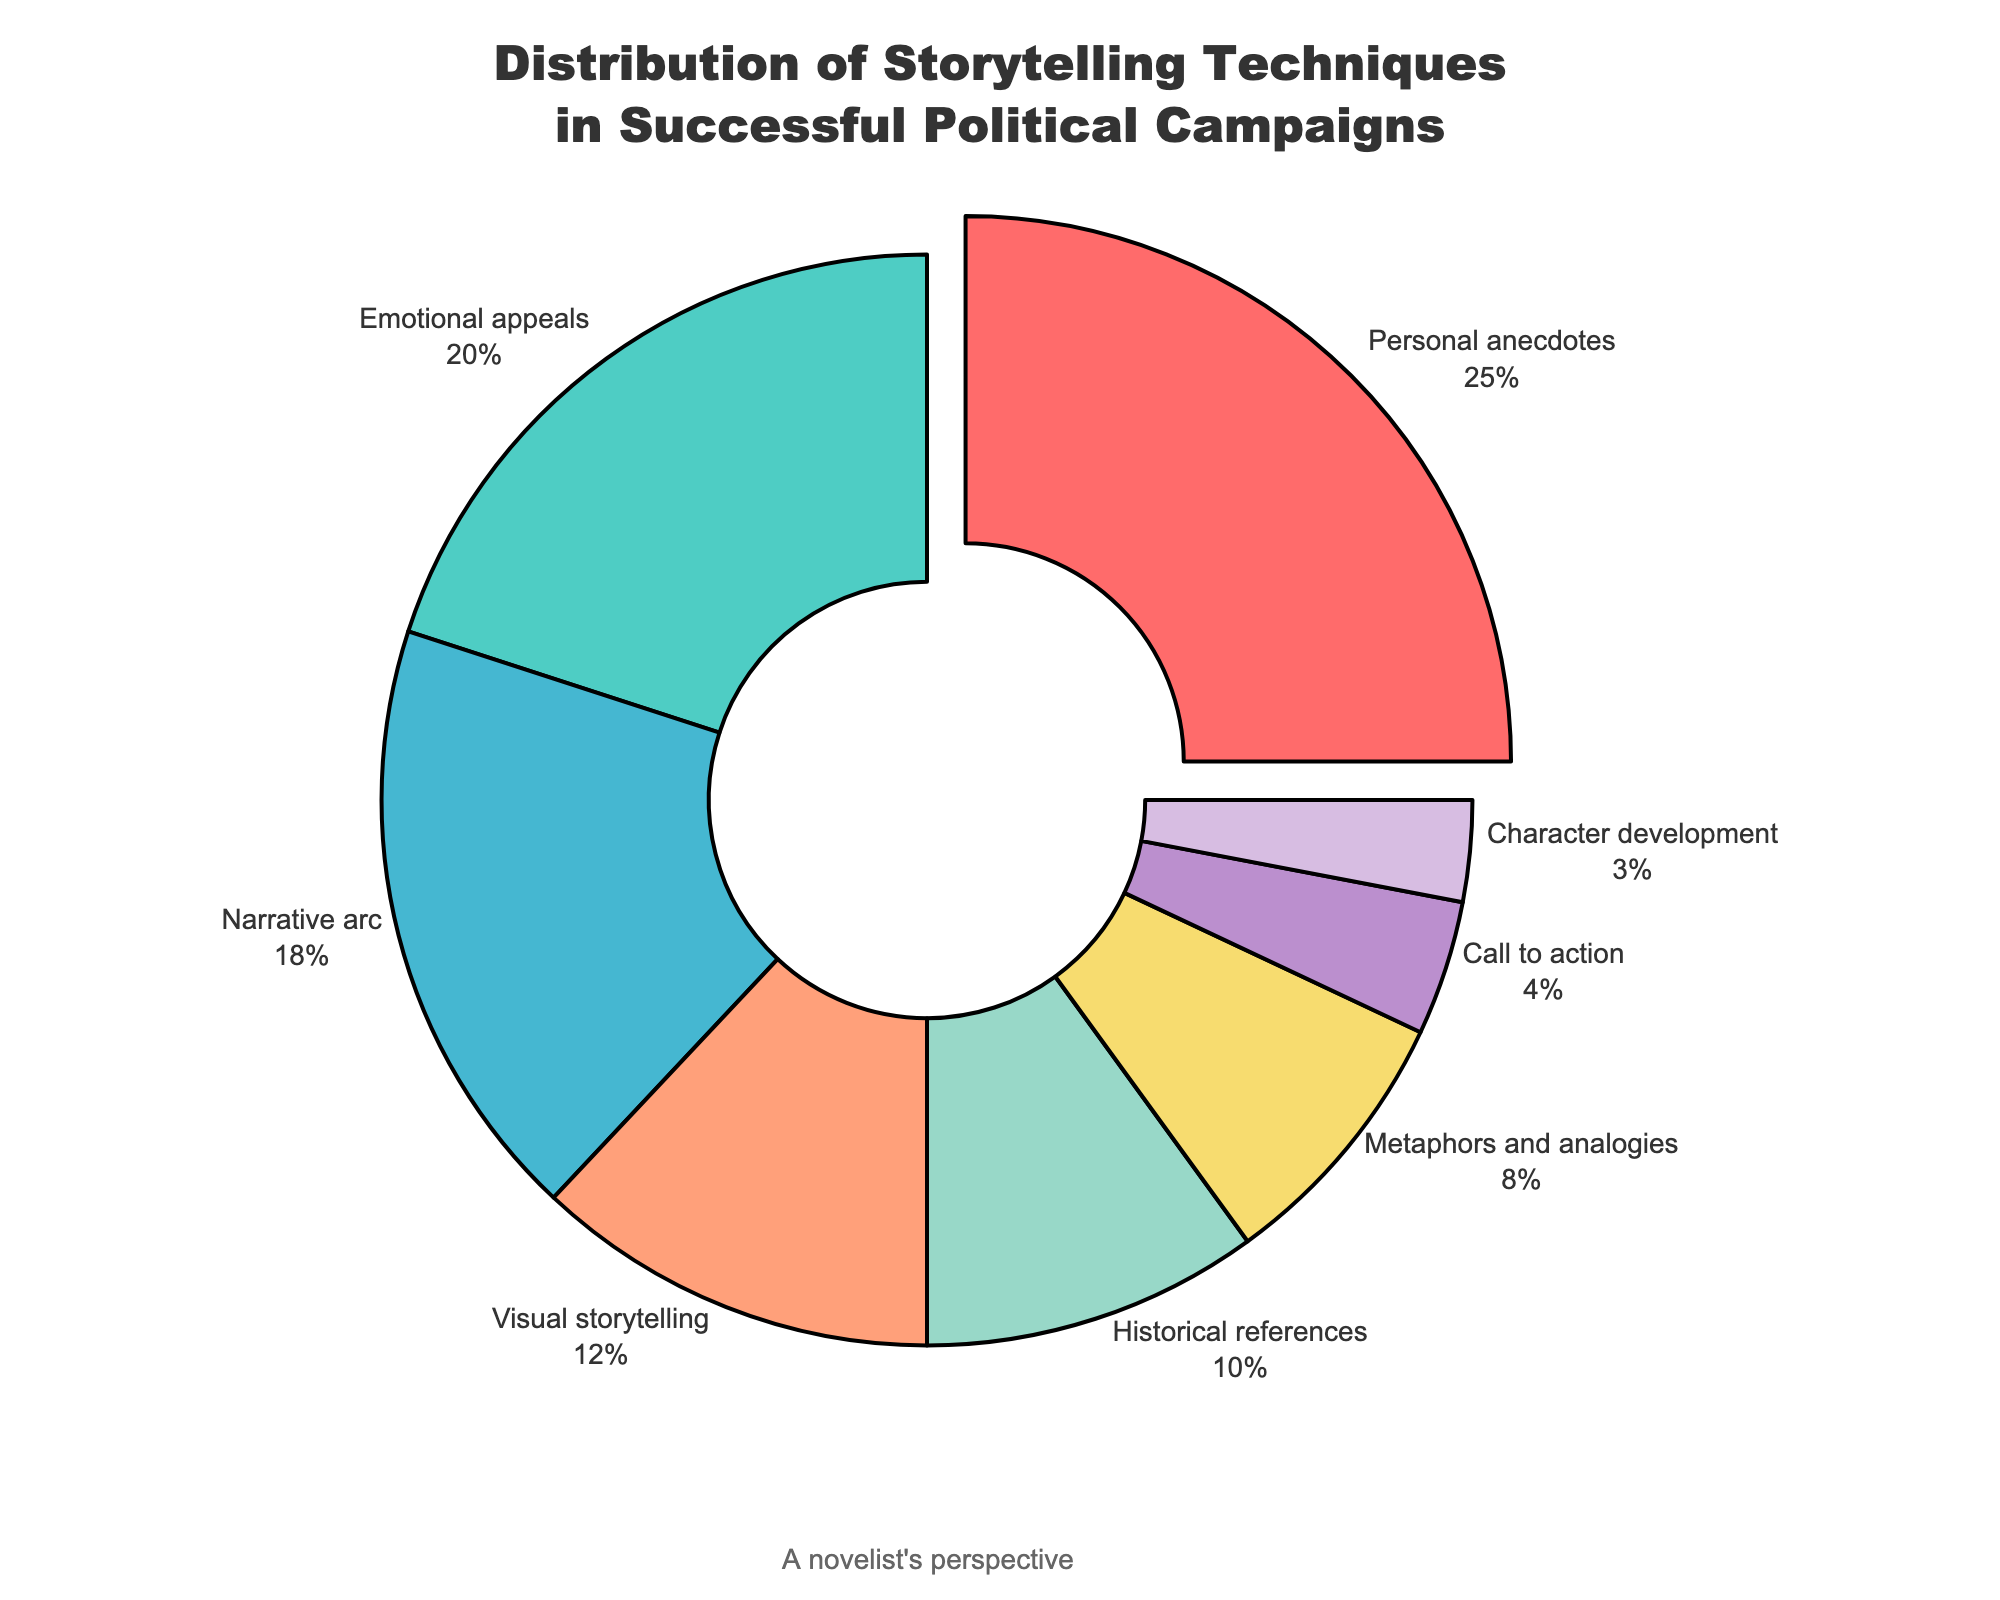Which storytelling technique is used the most in successful political campaigns? The figure indicates that Personal anecdotes have the highest percentage in the pie chart.
Answer: Personal anecdotes Which technique is used the least in successful political campaigns? The chart shows that Character development has the smallest slice.
Answer: Character development What is the combined percentage of Personal anecdotes and Emotional appeals? Sum the percentages of Personal anecdotes (25%) and Emotional appeals (20%). 25 + 20 = 45
Answer: 45% How much more is the percentage of Emotional appeals compared to Call to action? Subtract the percentage of Call to action (4%) from Emotional appeals (20%). 20 - 4 = 16
Answer: 16% Are there more combined percentages in Visual storytelling and Historical references, or Narrative arc alone? Visual storytelling (12%) + Historical references (10%) = 22. Compare this with Narrative arc (18%). 22 > 18
Answer: Visual storytelling and Historical references Which segment is displayed in red? Review the color assigned to each segment; the segment at the top with a small pull-out is colored red.
Answer: Personal anecdotes Which group has a mid-range percentage close to that of Visual storytelling? Visual storytelling is 12%. Nearby percentages are Historical references (10%) and Metaphors and analogies (8%). Historical references is the closest.
Answer: Historical references Compare the percentage of Metaphors and analogies to Call to action. Which is larger? Metaphors and analogies have 8%, and Call to action has 4%. 8 > 4
Answer: Metaphors and analogies Is the percentage of Narrative arc greater or less than the sum of Call to action and Character development? Narrative arc is 18%, the sum of Call to action (4%) and Character development (3%) is 4 + 3 = 7. 18 > 7
Answer: Greater What percentage of techniques account for half or more of the campaign strategies? Identify the techniques 50% or more by summing the highest percentages until the sum is at least 50%. Personal anecdotes (25%) + Emotional appeals (20%) + Narrative arc (18%). 25 + 20 + 18 = 63
Answer: 63% 